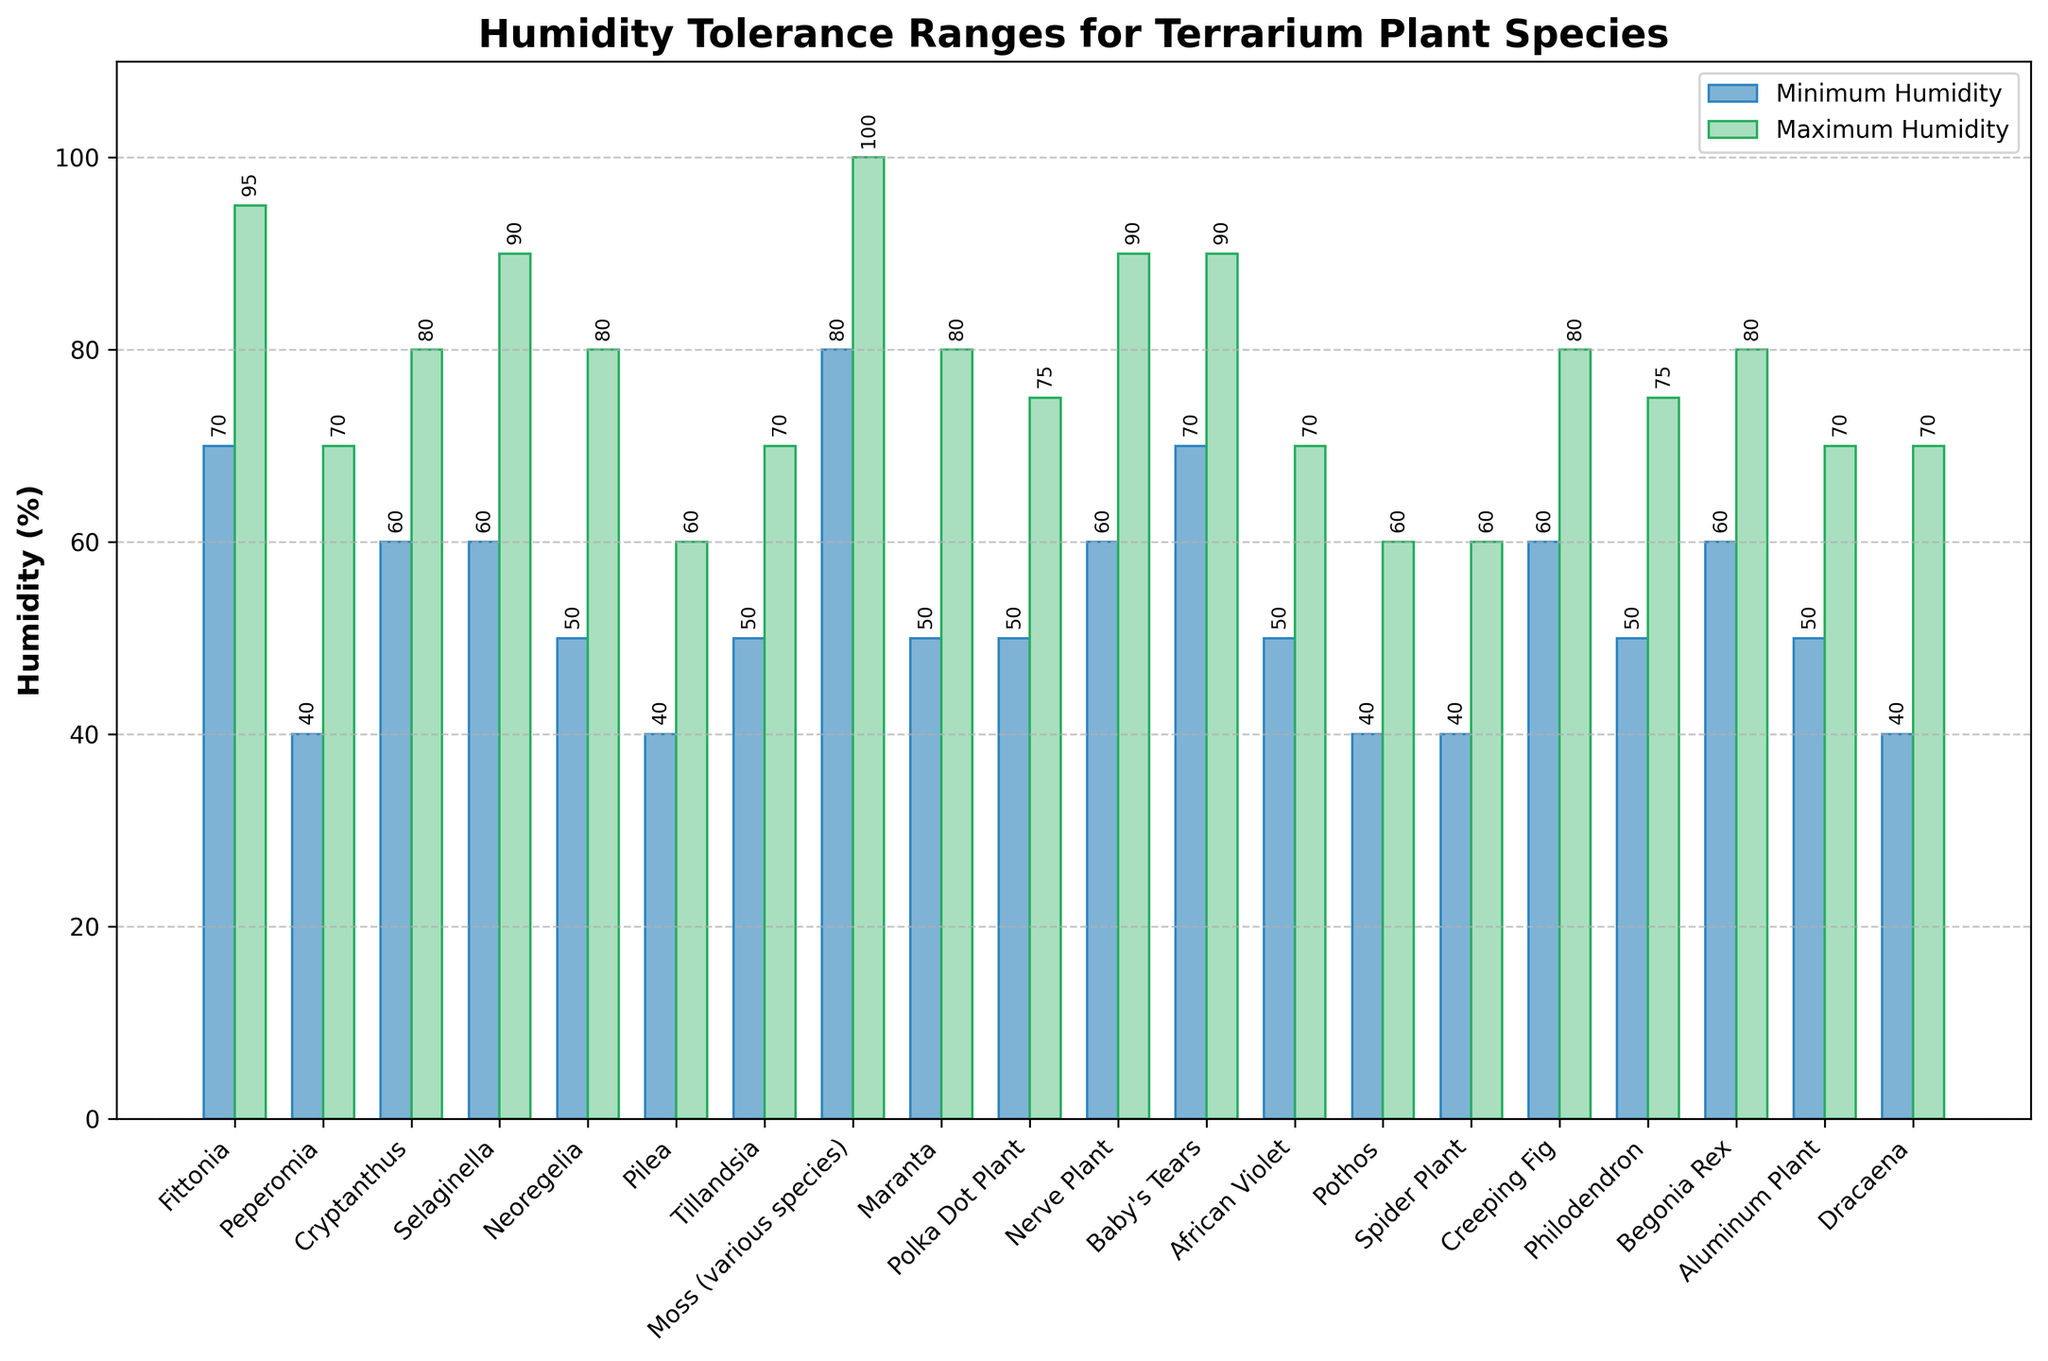Which plant species tolerates the highest maximum humidity level? The figure shows bars representing the maximum humidity levels for each plant species. Visual inspection reveals that Moss (various species) has the tallest bar for maximum humidity levels reaching 100%.
Answer: Moss (various species) What's the average minimum humidity tolerance for Fittonia and Baby's Tears? Fittonia has a minimum humidity of 70%, and Baby's Tears has a minimum humidity of 70%. The average is calculated by (70 + 70) / 2 = 70%.
Answer: 70% Which plant has a wider humidity tolerance range: Peperomia or Dracaena? Calculate the range by subtracting the minimum humidity from the maximum humidity for each plant. Peperomia: 70 - 40 = 30%; Dracaena: 70 - 40 = 30%. Both have the same tolerance range.
Answer: Both Which species has the smallest difference between its minimum and maximum humidity tolerance? Calculate the difference for each plant. The smallest difference is found by visual inspection of the bars' heights and verifying the calculations for each plant species. Pilea and Spider Plant both have the smallest difference of 20% (60 - 40).
Answer: Pilea and Spider Plant How does the minimum humidity tolerance of Nerve Plant compare to that of Selaginella? Nerve Plant has a minimum humidity tolerance of 60%, and Selaginella also has a minimum of 60%. By comparison, they are equal.
Answer: They are equal Which plant species have bars representing their minimum and maximum humidity ranges both colored in blue and green, respectively? Bars representing minimum humidity are colored blue, and bars representing maximum humidity are green. All plants have their bars in these colors as per the design description.
Answer: All plants Which plant species require a minimum humidity level of at least 60%? Plants with a minimum humidity of 60% or more include Fittonia, Cryptanthus, Selaginella, Moss (various species), Nerve Plant, Baby's Tears, Begonia Rex, Creeping Fig. This is identified by selecting bars equal to or above 60% for minimum humidity.
Answer: Fittonia, Cryptanthus, Selaginella, Moss (various species), Nerve Plant, Baby's Tears, Begonia Rex, Creeping Fig What's the median of the maximum humidity tolerances for Polka Dot Plant, Philodendron, and Tillandsia? Their maximum humidity levels are: Polka Dot Plant (75%), Philodendron (75%), Tillandsia (70%). Arrange in ascending order [70%, 75%, 75%]. The middle value is 75%.
Answer: 75% Which plant's minimum humidity tolerance is most comparable to Philodendron's maximum humidity tolerance? Philodendron's maximum humidity tolerance is 75%. The closest minimum value would be Baby's Tears and Fittonia, both having 70%, the nearest values to 75%. This is discovered by comparing each plant's values.
Answer: Baby's Tears, Fittonia For Spider Plant, what is the difference between its maximum and minimum humidity tolerances? Spider Plant has a maximum humidity of 60% and a minimum humidity of 40%. Therefore, the difference is calculated as 60 - 40  = 20%.
Answer: 20% 